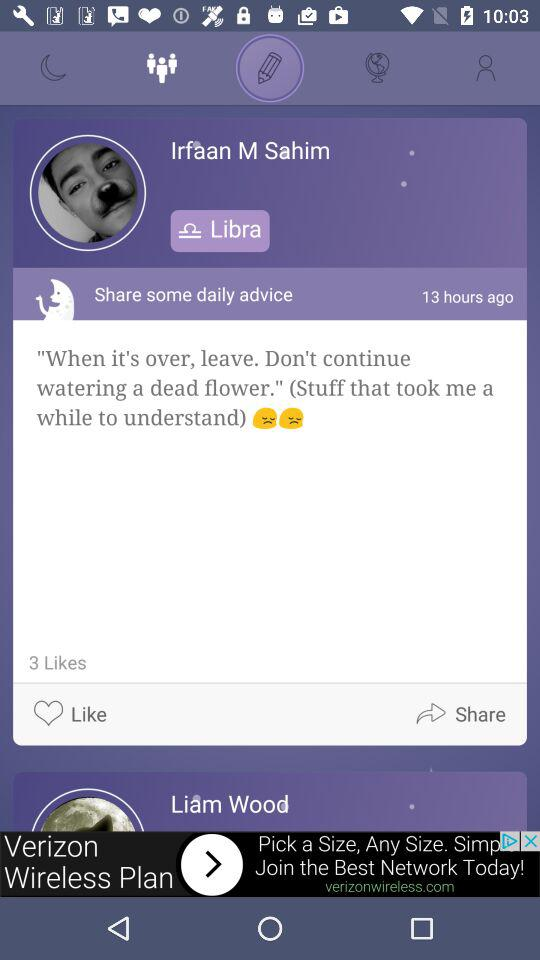What is the zodiac sign of Irfaan M Sahim? The zodiac sign is libra. 